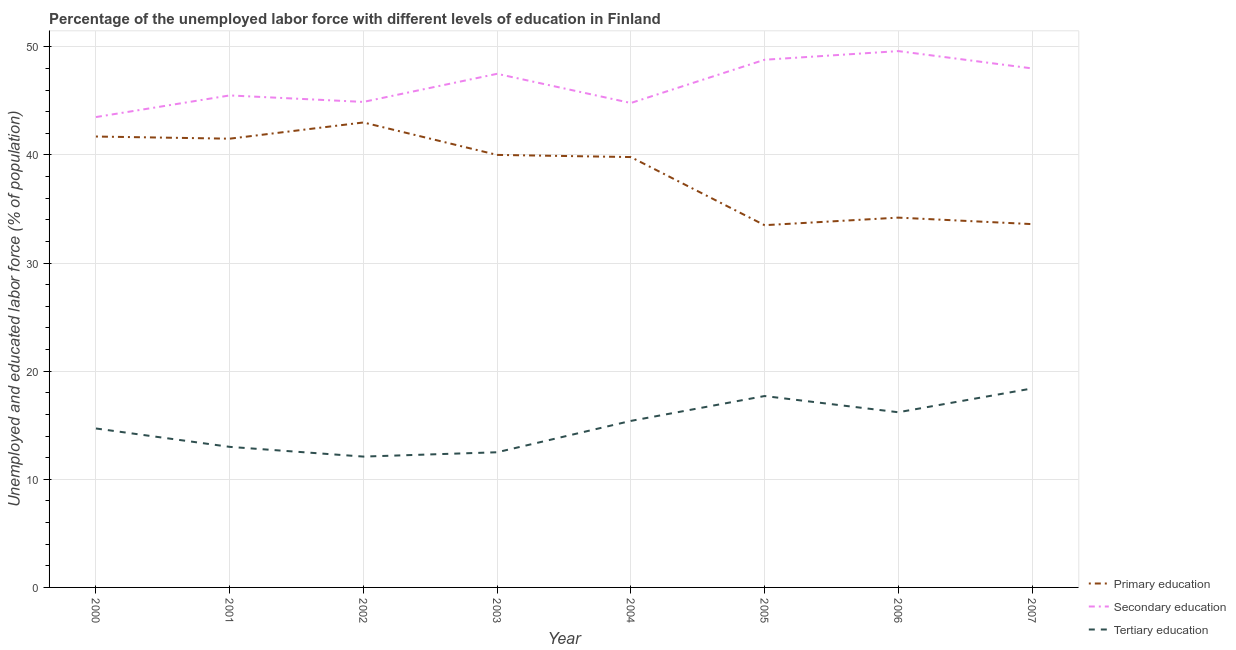Does the line corresponding to percentage of labor force who received secondary education intersect with the line corresponding to percentage of labor force who received tertiary education?
Your response must be concise. No. What is the percentage of labor force who received primary education in 2005?
Make the answer very short. 33.5. Across all years, what is the maximum percentage of labor force who received tertiary education?
Your response must be concise. 18.4. Across all years, what is the minimum percentage of labor force who received tertiary education?
Offer a terse response. 12.1. What is the total percentage of labor force who received primary education in the graph?
Ensure brevity in your answer.  307.3. What is the difference between the percentage of labor force who received secondary education in 2000 and that in 2004?
Make the answer very short. -1.3. What is the difference between the percentage of labor force who received tertiary education in 2005 and the percentage of labor force who received primary education in 2000?
Provide a short and direct response. -24. What is the average percentage of labor force who received tertiary education per year?
Your answer should be very brief. 15. In the year 2000, what is the difference between the percentage of labor force who received tertiary education and percentage of labor force who received primary education?
Your answer should be very brief. -27. What is the ratio of the percentage of labor force who received secondary education in 2005 to that in 2006?
Keep it short and to the point. 0.98. Is the percentage of labor force who received tertiary education in 2000 less than that in 2005?
Your answer should be compact. Yes. What is the difference between the highest and the second highest percentage of labor force who received primary education?
Offer a terse response. 1.3. What is the difference between the highest and the lowest percentage of labor force who received secondary education?
Make the answer very short. 6.1. Does the percentage of labor force who received primary education monotonically increase over the years?
Give a very brief answer. No. How many lines are there?
Give a very brief answer. 3. Are the values on the major ticks of Y-axis written in scientific E-notation?
Provide a succinct answer. No. What is the title of the graph?
Provide a succinct answer. Percentage of the unemployed labor force with different levels of education in Finland. Does "Refusal of sex" appear as one of the legend labels in the graph?
Your response must be concise. No. What is the label or title of the Y-axis?
Offer a very short reply. Unemployed and educated labor force (% of population). What is the Unemployed and educated labor force (% of population) in Primary education in 2000?
Keep it short and to the point. 41.7. What is the Unemployed and educated labor force (% of population) in Secondary education in 2000?
Give a very brief answer. 43.5. What is the Unemployed and educated labor force (% of population) of Tertiary education in 2000?
Give a very brief answer. 14.7. What is the Unemployed and educated labor force (% of population) of Primary education in 2001?
Provide a short and direct response. 41.5. What is the Unemployed and educated labor force (% of population) in Secondary education in 2001?
Offer a very short reply. 45.5. What is the Unemployed and educated labor force (% of population) of Primary education in 2002?
Offer a very short reply. 43. What is the Unemployed and educated labor force (% of population) of Secondary education in 2002?
Provide a short and direct response. 44.9. What is the Unemployed and educated labor force (% of population) in Tertiary education in 2002?
Offer a very short reply. 12.1. What is the Unemployed and educated labor force (% of population) of Primary education in 2003?
Your response must be concise. 40. What is the Unemployed and educated labor force (% of population) of Secondary education in 2003?
Provide a succinct answer. 47.5. What is the Unemployed and educated labor force (% of population) of Tertiary education in 2003?
Offer a terse response. 12.5. What is the Unemployed and educated labor force (% of population) in Primary education in 2004?
Your answer should be compact. 39.8. What is the Unemployed and educated labor force (% of population) in Secondary education in 2004?
Ensure brevity in your answer.  44.8. What is the Unemployed and educated labor force (% of population) in Tertiary education in 2004?
Ensure brevity in your answer.  15.4. What is the Unemployed and educated labor force (% of population) in Primary education in 2005?
Offer a terse response. 33.5. What is the Unemployed and educated labor force (% of population) of Secondary education in 2005?
Ensure brevity in your answer.  48.8. What is the Unemployed and educated labor force (% of population) of Tertiary education in 2005?
Provide a short and direct response. 17.7. What is the Unemployed and educated labor force (% of population) of Primary education in 2006?
Your answer should be very brief. 34.2. What is the Unemployed and educated labor force (% of population) in Secondary education in 2006?
Offer a very short reply. 49.6. What is the Unemployed and educated labor force (% of population) in Tertiary education in 2006?
Provide a succinct answer. 16.2. What is the Unemployed and educated labor force (% of population) of Primary education in 2007?
Offer a terse response. 33.6. What is the Unemployed and educated labor force (% of population) of Tertiary education in 2007?
Keep it short and to the point. 18.4. Across all years, what is the maximum Unemployed and educated labor force (% of population) in Primary education?
Offer a terse response. 43. Across all years, what is the maximum Unemployed and educated labor force (% of population) in Secondary education?
Your response must be concise. 49.6. Across all years, what is the maximum Unemployed and educated labor force (% of population) of Tertiary education?
Make the answer very short. 18.4. Across all years, what is the minimum Unemployed and educated labor force (% of population) of Primary education?
Offer a very short reply. 33.5. Across all years, what is the minimum Unemployed and educated labor force (% of population) in Secondary education?
Your answer should be compact. 43.5. Across all years, what is the minimum Unemployed and educated labor force (% of population) of Tertiary education?
Provide a succinct answer. 12.1. What is the total Unemployed and educated labor force (% of population) in Primary education in the graph?
Your answer should be compact. 307.3. What is the total Unemployed and educated labor force (% of population) of Secondary education in the graph?
Provide a succinct answer. 372.6. What is the total Unemployed and educated labor force (% of population) of Tertiary education in the graph?
Offer a terse response. 120. What is the difference between the Unemployed and educated labor force (% of population) in Secondary education in 2000 and that in 2001?
Make the answer very short. -2. What is the difference between the Unemployed and educated labor force (% of population) of Secondary education in 2000 and that in 2002?
Ensure brevity in your answer.  -1.4. What is the difference between the Unemployed and educated labor force (% of population) of Tertiary education in 2000 and that in 2002?
Your answer should be very brief. 2.6. What is the difference between the Unemployed and educated labor force (% of population) of Secondary education in 2000 and that in 2004?
Offer a terse response. -1.3. What is the difference between the Unemployed and educated labor force (% of population) in Secondary education in 2000 and that in 2005?
Keep it short and to the point. -5.3. What is the difference between the Unemployed and educated labor force (% of population) of Secondary education in 2000 and that in 2006?
Your answer should be compact. -6.1. What is the difference between the Unemployed and educated labor force (% of population) of Primary education in 2000 and that in 2007?
Keep it short and to the point. 8.1. What is the difference between the Unemployed and educated labor force (% of population) in Secondary education in 2000 and that in 2007?
Give a very brief answer. -4.5. What is the difference between the Unemployed and educated labor force (% of population) of Tertiary education in 2000 and that in 2007?
Offer a very short reply. -3.7. What is the difference between the Unemployed and educated labor force (% of population) of Primary education in 2001 and that in 2002?
Your response must be concise. -1.5. What is the difference between the Unemployed and educated labor force (% of population) in Secondary education in 2001 and that in 2002?
Provide a succinct answer. 0.6. What is the difference between the Unemployed and educated labor force (% of population) of Primary education in 2001 and that in 2003?
Make the answer very short. 1.5. What is the difference between the Unemployed and educated labor force (% of population) in Secondary education in 2001 and that in 2003?
Give a very brief answer. -2. What is the difference between the Unemployed and educated labor force (% of population) in Primary education in 2001 and that in 2004?
Your answer should be very brief. 1.7. What is the difference between the Unemployed and educated labor force (% of population) in Primary education in 2001 and that in 2005?
Offer a terse response. 8. What is the difference between the Unemployed and educated labor force (% of population) of Secondary education in 2001 and that in 2007?
Provide a succinct answer. -2.5. What is the difference between the Unemployed and educated labor force (% of population) of Primary education in 2002 and that in 2003?
Ensure brevity in your answer.  3. What is the difference between the Unemployed and educated labor force (% of population) in Secondary education in 2002 and that in 2003?
Offer a terse response. -2.6. What is the difference between the Unemployed and educated labor force (% of population) of Tertiary education in 2002 and that in 2003?
Make the answer very short. -0.4. What is the difference between the Unemployed and educated labor force (% of population) of Primary education in 2002 and that in 2004?
Provide a short and direct response. 3.2. What is the difference between the Unemployed and educated labor force (% of population) in Secondary education in 2002 and that in 2004?
Make the answer very short. 0.1. What is the difference between the Unemployed and educated labor force (% of population) in Primary education in 2002 and that in 2005?
Provide a succinct answer. 9.5. What is the difference between the Unemployed and educated labor force (% of population) in Secondary education in 2002 and that in 2005?
Provide a succinct answer. -3.9. What is the difference between the Unemployed and educated labor force (% of population) of Secondary education in 2002 and that in 2006?
Your response must be concise. -4.7. What is the difference between the Unemployed and educated labor force (% of population) of Secondary education in 2002 and that in 2007?
Your response must be concise. -3.1. What is the difference between the Unemployed and educated labor force (% of population) in Tertiary education in 2002 and that in 2007?
Your answer should be compact. -6.3. What is the difference between the Unemployed and educated labor force (% of population) of Tertiary education in 2003 and that in 2004?
Provide a succinct answer. -2.9. What is the difference between the Unemployed and educated labor force (% of population) of Secondary education in 2003 and that in 2005?
Offer a terse response. -1.3. What is the difference between the Unemployed and educated labor force (% of population) in Tertiary education in 2003 and that in 2005?
Keep it short and to the point. -5.2. What is the difference between the Unemployed and educated labor force (% of population) of Tertiary education in 2003 and that in 2006?
Offer a very short reply. -3.7. What is the difference between the Unemployed and educated labor force (% of population) in Primary education in 2003 and that in 2007?
Your answer should be compact. 6.4. What is the difference between the Unemployed and educated labor force (% of population) of Secondary education in 2003 and that in 2007?
Your answer should be compact. -0.5. What is the difference between the Unemployed and educated labor force (% of population) in Tertiary education in 2003 and that in 2007?
Give a very brief answer. -5.9. What is the difference between the Unemployed and educated labor force (% of population) in Primary education in 2004 and that in 2005?
Offer a very short reply. 6.3. What is the difference between the Unemployed and educated labor force (% of population) of Secondary education in 2004 and that in 2005?
Provide a short and direct response. -4. What is the difference between the Unemployed and educated labor force (% of population) of Primary education in 2004 and that in 2006?
Your answer should be very brief. 5.6. What is the difference between the Unemployed and educated labor force (% of population) in Secondary education in 2004 and that in 2006?
Offer a terse response. -4.8. What is the difference between the Unemployed and educated labor force (% of population) of Primary education in 2004 and that in 2007?
Make the answer very short. 6.2. What is the difference between the Unemployed and educated labor force (% of population) in Primary education in 2005 and that in 2007?
Your response must be concise. -0.1. What is the difference between the Unemployed and educated labor force (% of population) in Secondary education in 2005 and that in 2007?
Offer a very short reply. 0.8. What is the difference between the Unemployed and educated labor force (% of population) of Primary education in 2006 and that in 2007?
Keep it short and to the point. 0.6. What is the difference between the Unemployed and educated labor force (% of population) in Primary education in 2000 and the Unemployed and educated labor force (% of population) in Secondary education in 2001?
Your response must be concise. -3.8. What is the difference between the Unemployed and educated labor force (% of population) in Primary education in 2000 and the Unemployed and educated labor force (% of population) in Tertiary education in 2001?
Keep it short and to the point. 28.7. What is the difference between the Unemployed and educated labor force (% of population) of Secondary education in 2000 and the Unemployed and educated labor force (% of population) of Tertiary education in 2001?
Your answer should be compact. 30.5. What is the difference between the Unemployed and educated labor force (% of population) in Primary education in 2000 and the Unemployed and educated labor force (% of population) in Secondary education in 2002?
Keep it short and to the point. -3.2. What is the difference between the Unemployed and educated labor force (% of population) in Primary education in 2000 and the Unemployed and educated labor force (% of population) in Tertiary education in 2002?
Your response must be concise. 29.6. What is the difference between the Unemployed and educated labor force (% of population) in Secondary education in 2000 and the Unemployed and educated labor force (% of population) in Tertiary education in 2002?
Make the answer very short. 31.4. What is the difference between the Unemployed and educated labor force (% of population) of Primary education in 2000 and the Unemployed and educated labor force (% of population) of Tertiary education in 2003?
Offer a terse response. 29.2. What is the difference between the Unemployed and educated labor force (% of population) in Primary education in 2000 and the Unemployed and educated labor force (% of population) in Tertiary education in 2004?
Offer a terse response. 26.3. What is the difference between the Unemployed and educated labor force (% of population) in Secondary education in 2000 and the Unemployed and educated labor force (% of population) in Tertiary education in 2004?
Make the answer very short. 28.1. What is the difference between the Unemployed and educated labor force (% of population) of Primary education in 2000 and the Unemployed and educated labor force (% of population) of Secondary education in 2005?
Your answer should be very brief. -7.1. What is the difference between the Unemployed and educated labor force (% of population) in Primary education in 2000 and the Unemployed and educated labor force (% of population) in Tertiary education in 2005?
Offer a terse response. 24. What is the difference between the Unemployed and educated labor force (% of population) in Secondary education in 2000 and the Unemployed and educated labor force (% of population) in Tertiary education in 2005?
Offer a terse response. 25.8. What is the difference between the Unemployed and educated labor force (% of population) of Primary education in 2000 and the Unemployed and educated labor force (% of population) of Secondary education in 2006?
Keep it short and to the point. -7.9. What is the difference between the Unemployed and educated labor force (% of population) of Primary education in 2000 and the Unemployed and educated labor force (% of population) of Tertiary education in 2006?
Offer a very short reply. 25.5. What is the difference between the Unemployed and educated labor force (% of population) of Secondary education in 2000 and the Unemployed and educated labor force (% of population) of Tertiary education in 2006?
Offer a very short reply. 27.3. What is the difference between the Unemployed and educated labor force (% of population) in Primary education in 2000 and the Unemployed and educated labor force (% of population) in Secondary education in 2007?
Keep it short and to the point. -6.3. What is the difference between the Unemployed and educated labor force (% of population) of Primary education in 2000 and the Unemployed and educated labor force (% of population) of Tertiary education in 2007?
Keep it short and to the point. 23.3. What is the difference between the Unemployed and educated labor force (% of population) in Secondary education in 2000 and the Unemployed and educated labor force (% of population) in Tertiary education in 2007?
Your response must be concise. 25.1. What is the difference between the Unemployed and educated labor force (% of population) in Primary education in 2001 and the Unemployed and educated labor force (% of population) in Tertiary education in 2002?
Make the answer very short. 29.4. What is the difference between the Unemployed and educated labor force (% of population) of Secondary education in 2001 and the Unemployed and educated labor force (% of population) of Tertiary education in 2002?
Provide a short and direct response. 33.4. What is the difference between the Unemployed and educated labor force (% of population) in Primary education in 2001 and the Unemployed and educated labor force (% of population) in Secondary education in 2003?
Offer a very short reply. -6. What is the difference between the Unemployed and educated labor force (% of population) of Primary education in 2001 and the Unemployed and educated labor force (% of population) of Tertiary education in 2003?
Provide a short and direct response. 29. What is the difference between the Unemployed and educated labor force (% of population) in Primary education in 2001 and the Unemployed and educated labor force (% of population) in Secondary education in 2004?
Keep it short and to the point. -3.3. What is the difference between the Unemployed and educated labor force (% of population) in Primary education in 2001 and the Unemployed and educated labor force (% of population) in Tertiary education in 2004?
Offer a terse response. 26.1. What is the difference between the Unemployed and educated labor force (% of population) in Secondary education in 2001 and the Unemployed and educated labor force (% of population) in Tertiary education in 2004?
Offer a terse response. 30.1. What is the difference between the Unemployed and educated labor force (% of population) of Primary education in 2001 and the Unemployed and educated labor force (% of population) of Secondary education in 2005?
Provide a short and direct response. -7.3. What is the difference between the Unemployed and educated labor force (% of population) of Primary education in 2001 and the Unemployed and educated labor force (% of population) of Tertiary education in 2005?
Your answer should be very brief. 23.8. What is the difference between the Unemployed and educated labor force (% of population) in Secondary education in 2001 and the Unemployed and educated labor force (% of population) in Tertiary education in 2005?
Your answer should be compact. 27.8. What is the difference between the Unemployed and educated labor force (% of population) of Primary education in 2001 and the Unemployed and educated labor force (% of population) of Secondary education in 2006?
Your answer should be very brief. -8.1. What is the difference between the Unemployed and educated labor force (% of population) of Primary education in 2001 and the Unemployed and educated labor force (% of population) of Tertiary education in 2006?
Keep it short and to the point. 25.3. What is the difference between the Unemployed and educated labor force (% of population) in Secondary education in 2001 and the Unemployed and educated labor force (% of population) in Tertiary education in 2006?
Provide a succinct answer. 29.3. What is the difference between the Unemployed and educated labor force (% of population) in Primary education in 2001 and the Unemployed and educated labor force (% of population) in Secondary education in 2007?
Offer a very short reply. -6.5. What is the difference between the Unemployed and educated labor force (% of population) in Primary education in 2001 and the Unemployed and educated labor force (% of population) in Tertiary education in 2007?
Give a very brief answer. 23.1. What is the difference between the Unemployed and educated labor force (% of population) in Secondary education in 2001 and the Unemployed and educated labor force (% of population) in Tertiary education in 2007?
Your answer should be compact. 27.1. What is the difference between the Unemployed and educated labor force (% of population) of Primary education in 2002 and the Unemployed and educated labor force (% of population) of Tertiary education in 2003?
Make the answer very short. 30.5. What is the difference between the Unemployed and educated labor force (% of population) of Secondary education in 2002 and the Unemployed and educated labor force (% of population) of Tertiary education in 2003?
Offer a terse response. 32.4. What is the difference between the Unemployed and educated labor force (% of population) of Primary education in 2002 and the Unemployed and educated labor force (% of population) of Tertiary education in 2004?
Give a very brief answer. 27.6. What is the difference between the Unemployed and educated labor force (% of population) of Secondary education in 2002 and the Unemployed and educated labor force (% of population) of Tertiary education in 2004?
Your response must be concise. 29.5. What is the difference between the Unemployed and educated labor force (% of population) in Primary education in 2002 and the Unemployed and educated labor force (% of population) in Tertiary education in 2005?
Ensure brevity in your answer.  25.3. What is the difference between the Unemployed and educated labor force (% of population) of Secondary education in 2002 and the Unemployed and educated labor force (% of population) of Tertiary education in 2005?
Offer a very short reply. 27.2. What is the difference between the Unemployed and educated labor force (% of population) of Primary education in 2002 and the Unemployed and educated labor force (% of population) of Secondary education in 2006?
Ensure brevity in your answer.  -6.6. What is the difference between the Unemployed and educated labor force (% of population) in Primary education in 2002 and the Unemployed and educated labor force (% of population) in Tertiary education in 2006?
Provide a succinct answer. 26.8. What is the difference between the Unemployed and educated labor force (% of population) of Secondary education in 2002 and the Unemployed and educated labor force (% of population) of Tertiary education in 2006?
Give a very brief answer. 28.7. What is the difference between the Unemployed and educated labor force (% of population) of Primary education in 2002 and the Unemployed and educated labor force (% of population) of Tertiary education in 2007?
Keep it short and to the point. 24.6. What is the difference between the Unemployed and educated labor force (% of population) of Secondary education in 2002 and the Unemployed and educated labor force (% of population) of Tertiary education in 2007?
Provide a short and direct response. 26.5. What is the difference between the Unemployed and educated labor force (% of population) of Primary education in 2003 and the Unemployed and educated labor force (% of population) of Secondary education in 2004?
Your answer should be very brief. -4.8. What is the difference between the Unemployed and educated labor force (% of population) in Primary education in 2003 and the Unemployed and educated labor force (% of population) in Tertiary education in 2004?
Provide a short and direct response. 24.6. What is the difference between the Unemployed and educated labor force (% of population) in Secondary education in 2003 and the Unemployed and educated labor force (% of population) in Tertiary education in 2004?
Ensure brevity in your answer.  32.1. What is the difference between the Unemployed and educated labor force (% of population) of Primary education in 2003 and the Unemployed and educated labor force (% of population) of Secondary education in 2005?
Your answer should be very brief. -8.8. What is the difference between the Unemployed and educated labor force (% of population) in Primary education in 2003 and the Unemployed and educated labor force (% of population) in Tertiary education in 2005?
Ensure brevity in your answer.  22.3. What is the difference between the Unemployed and educated labor force (% of population) in Secondary education in 2003 and the Unemployed and educated labor force (% of population) in Tertiary education in 2005?
Make the answer very short. 29.8. What is the difference between the Unemployed and educated labor force (% of population) of Primary education in 2003 and the Unemployed and educated labor force (% of population) of Secondary education in 2006?
Keep it short and to the point. -9.6. What is the difference between the Unemployed and educated labor force (% of population) in Primary education in 2003 and the Unemployed and educated labor force (% of population) in Tertiary education in 2006?
Provide a succinct answer. 23.8. What is the difference between the Unemployed and educated labor force (% of population) of Secondary education in 2003 and the Unemployed and educated labor force (% of population) of Tertiary education in 2006?
Give a very brief answer. 31.3. What is the difference between the Unemployed and educated labor force (% of population) of Primary education in 2003 and the Unemployed and educated labor force (% of population) of Tertiary education in 2007?
Keep it short and to the point. 21.6. What is the difference between the Unemployed and educated labor force (% of population) of Secondary education in 2003 and the Unemployed and educated labor force (% of population) of Tertiary education in 2007?
Give a very brief answer. 29.1. What is the difference between the Unemployed and educated labor force (% of population) of Primary education in 2004 and the Unemployed and educated labor force (% of population) of Tertiary education in 2005?
Ensure brevity in your answer.  22.1. What is the difference between the Unemployed and educated labor force (% of population) in Secondary education in 2004 and the Unemployed and educated labor force (% of population) in Tertiary education in 2005?
Keep it short and to the point. 27.1. What is the difference between the Unemployed and educated labor force (% of population) in Primary education in 2004 and the Unemployed and educated labor force (% of population) in Secondary education in 2006?
Keep it short and to the point. -9.8. What is the difference between the Unemployed and educated labor force (% of population) of Primary education in 2004 and the Unemployed and educated labor force (% of population) of Tertiary education in 2006?
Ensure brevity in your answer.  23.6. What is the difference between the Unemployed and educated labor force (% of population) in Secondary education in 2004 and the Unemployed and educated labor force (% of population) in Tertiary education in 2006?
Your response must be concise. 28.6. What is the difference between the Unemployed and educated labor force (% of population) in Primary education in 2004 and the Unemployed and educated labor force (% of population) in Tertiary education in 2007?
Offer a terse response. 21.4. What is the difference between the Unemployed and educated labor force (% of population) of Secondary education in 2004 and the Unemployed and educated labor force (% of population) of Tertiary education in 2007?
Your answer should be compact. 26.4. What is the difference between the Unemployed and educated labor force (% of population) in Primary education in 2005 and the Unemployed and educated labor force (% of population) in Secondary education in 2006?
Keep it short and to the point. -16.1. What is the difference between the Unemployed and educated labor force (% of population) of Primary education in 2005 and the Unemployed and educated labor force (% of population) of Tertiary education in 2006?
Make the answer very short. 17.3. What is the difference between the Unemployed and educated labor force (% of population) of Secondary education in 2005 and the Unemployed and educated labor force (% of population) of Tertiary education in 2006?
Keep it short and to the point. 32.6. What is the difference between the Unemployed and educated labor force (% of population) in Primary education in 2005 and the Unemployed and educated labor force (% of population) in Tertiary education in 2007?
Your response must be concise. 15.1. What is the difference between the Unemployed and educated labor force (% of population) of Secondary education in 2005 and the Unemployed and educated labor force (% of population) of Tertiary education in 2007?
Provide a short and direct response. 30.4. What is the difference between the Unemployed and educated labor force (% of population) of Primary education in 2006 and the Unemployed and educated labor force (% of population) of Tertiary education in 2007?
Your answer should be very brief. 15.8. What is the difference between the Unemployed and educated labor force (% of population) of Secondary education in 2006 and the Unemployed and educated labor force (% of population) of Tertiary education in 2007?
Offer a very short reply. 31.2. What is the average Unemployed and educated labor force (% of population) of Primary education per year?
Your response must be concise. 38.41. What is the average Unemployed and educated labor force (% of population) in Secondary education per year?
Your response must be concise. 46.58. In the year 2000, what is the difference between the Unemployed and educated labor force (% of population) of Primary education and Unemployed and educated labor force (% of population) of Tertiary education?
Make the answer very short. 27. In the year 2000, what is the difference between the Unemployed and educated labor force (% of population) of Secondary education and Unemployed and educated labor force (% of population) of Tertiary education?
Offer a very short reply. 28.8. In the year 2001, what is the difference between the Unemployed and educated labor force (% of population) in Primary education and Unemployed and educated labor force (% of population) in Secondary education?
Offer a very short reply. -4. In the year 2001, what is the difference between the Unemployed and educated labor force (% of population) of Secondary education and Unemployed and educated labor force (% of population) of Tertiary education?
Your response must be concise. 32.5. In the year 2002, what is the difference between the Unemployed and educated labor force (% of population) in Primary education and Unemployed and educated labor force (% of population) in Tertiary education?
Your answer should be compact. 30.9. In the year 2002, what is the difference between the Unemployed and educated labor force (% of population) in Secondary education and Unemployed and educated labor force (% of population) in Tertiary education?
Your answer should be very brief. 32.8. In the year 2003, what is the difference between the Unemployed and educated labor force (% of population) in Primary education and Unemployed and educated labor force (% of population) in Tertiary education?
Give a very brief answer. 27.5. In the year 2004, what is the difference between the Unemployed and educated labor force (% of population) in Primary education and Unemployed and educated labor force (% of population) in Secondary education?
Ensure brevity in your answer.  -5. In the year 2004, what is the difference between the Unemployed and educated labor force (% of population) of Primary education and Unemployed and educated labor force (% of population) of Tertiary education?
Your response must be concise. 24.4. In the year 2004, what is the difference between the Unemployed and educated labor force (% of population) in Secondary education and Unemployed and educated labor force (% of population) in Tertiary education?
Ensure brevity in your answer.  29.4. In the year 2005, what is the difference between the Unemployed and educated labor force (% of population) of Primary education and Unemployed and educated labor force (% of population) of Secondary education?
Offer a very short reply. -15.3. In the year 2005, what is the difference between the Unemployed and educated labor force (% of population) of Secondary education and Unemployed and educated labor force (% of population) of Tertiary education?
Your response must be concise. 31.1. In the year 2006, what is the difference between the Unemployed and educated labor force (% of population) of Primary education and Unemployed and educated labor force (% of population) of Secondary education?
Provide a succinct answer. -15.4. In the year 2006, what is the difference between the Unemployed and educated labor force (% of population) in Secondary education and Unemployed and educated labor force (% of population) in Tertiary education?
Give a very brief answer. 33.4. In the year 2007, what is the difference between the Unemployed and educated labor force (% of population) in Primary education and Unemployed and educated labor force (% of population) in Secondary education?
Make the answer very short. -14.4. In the year 2007, what is the difference between the Unemployed and educated labor force (% of population) in Secondary education and Unemployed and educated labor force (% of population) in Tertiary education?
Offer a terse response. 29.6. What is the ratio of the Unemployed and educated labor force (% of population) of Primary education in 2000 to that in 2001?
Give a very brief answer. 1. What is the ratio of the Unemployed and educated labor force (% of population) of Secondary education in 2000 to that in 2001?
Your answer should be compact. 0.96. What is the ratio of the Unemployed and educated labor force (% of population) of Tertiary education in 2000 to that in 2001?
Your response must be concise. 1.13. What is the ratio of the Unemployed and educated labor force (% of population) in Primary education in 2000 to that in 2002?
Make the answer very short. 0.97. What is the ratio of the Unemployed and educated labor force (% of population) of Secondary education in 2000 to that in 2002?
Make the answer very short. 0.97. What is the ratio of the Unemployed and educated labor force (% of population) in Tertiary education in 2000 to that in 2002?
Give a very brief answer. 1.21. What is the ratio of the Unemployed and educated labor force (% of population) of Primary education in 2000 to that in 2003?
Your response must be concise. 1.04. What is the ratio of the Unemployed and educated labor force (% of population) in Secondary education in 2000 to that in 2003?
Your answer should be very brief. 0.92. What is the ratio of the Unemployed and educated labor force (% of population) of Tertiary education in 2000 to that in 2003?
Give a very brief answer. 1.18. What is the ratio of the Unemployed and educated labor force (% of population) in Primary education in 2000 to that in 2004?
Keep it short and to the point. 1.05. What is the ratio of the Unemployed and educated labor force (% of population) of Secondary education in 2000 to that in 2004?
Make the answer very short. 0.97. What is the ratio of the Unemployed and educated labor force (% of population) of Tertiary education in 2000 to that in 2004?
Your answer should be very brief. 0.95. What is the ratio of the Unemployed and educated labor force (% of population) of Primary education in 2000 to that in 2005?
Offer a terse response. 1.24. What is the ratio of the Unemployed and educated labor force (% of population) of Secondary education in 2000 to that in 2005?
Your response must be concise. 0.89. What is the ratio of the Unemployed and educated labor force (% of population) in Tertiary education in 2000 to that in 2005?
Ensure brevity in your answer.  0.83. What is the ratio of the Unemployed and educated labor force (% of population) of Primary education in 2000 to that in 2006?
Ensure brevity in your answer.  1.22. What is the ratio of the Unemployed and educated labor force (% of population) in Secondary education in 2000 to that in 2006?
Offer a very short reply. 0.88. What is the ratio of the Unemployed and educated labor force (% of population) of Tertiary education in 2000 to that in 2006?
Offer a very short reply. 0.91. What is the ratio of the Unemployed and educated labor force (% of population) of Primary education in 2000 to that in 2007?
Provide a succinct answer. 1.24. What is the ratio of the Unemployed and educated labor force (% of population) of Secondary education in 2000 to that in 2007?
Offer a terse response. 0.91. What is the ratio of the Unemployed and educated labor force (% of population) of Tertiary education in 2000 to that in 2007?
Ensure brevity in your answer.  0.8. What is the ratio of the Unemployed and educated labor force (% of population) of Primary education in 2001 to that in 2002?
Keep it short and to the point. 0.97. What is the ratio of the Unemployed and educated labor force (% of population) of Secondary education in 2001 to that in 2002?
Provide a succinct answer. 1.01. What is the ratio of the Unemployed and educated labor force (% of population) of Tertiary education in 2001 to that in 2002?
Make the answer very short. 1.07. What is the ratio of the Unemployed and educated labor force (% of population) in Primary education in 2001 to that in 2003?
Give a very brief answer. 1.04. What is the ratio of the Unemployed and educated labor force (% of population) of Secondary education in 2001 to that in 2003?
Offer a terse response. 0.96. What is the ratio of the Unemployed and educated labor force (% of population) of Primary education in 2001 to that in 2004?
Ensure brevity in your answer.  1.04. What is the ratio of the Unemployed and educated labor force (% of population) of Secondary education in 2001 to that in 2004?
Your answer should be compact. 1.02. What is the ratio of the Unemployed and educated labor force (% of population) of Tertiary education in 2001 to that in 2004?
Your response must be concise. 0.84. What is the ratio of the Unemployed and educated labor force (% of population) in Primary education in 2001 to that in 2005?
Your answer should be very brief. 1.24. What is the ratio of the Unemployed and educated labor force (% of population) of Secondary education in 2001 to that in 2005?
Offer a very short reply. 0.93. What is the ratio of the Unemployed and educated labor force (% of population) of Tertiary education in 2001 to that in 2005?
Give a very brief answer. 0.73. What is the ratio of the Unemployed and educated labor force (% of population) in Primary education in 2001 to that in 2006?
Keep it short and to the point. 1.21. What is the ratio of the Unemployed and educated labor force (% of population) of Secondary education in 2001 to that in 2006?
Your response must be concise. 0.92. What is the ratio of the Unemployed and educated labor force (% of population) of Tertiary education in 2001 to that in 2006?
Provide a short and direct response. 0.8. What is the ratio of the Unemployed and educated labor force (% of population) in Primary education in 2001 to that in 2007?
Provide a succinct answer. 1.24. What is the ratio of the Unemployed and educated labor force (% of population) in Secondary education in 2001 to that in 2007?
Your response must be concise. 0.95. What is the ratio of the Unemployed and educated labor force (% of population) of Tertiary education in 2001 to that in 2007?
Your response must be concise. 0.71. What is the ratio of the Unemployed and educated labor force (% of population) of Primary education in 2002 to that in 2003?
Provide a succinct answer. 1.07. What is the ratio of the Unemployed and educated labor force (% of population) in Secondary education in 2002 to that in 2003?
Ensure brevity in your answer.  0.95. What is the ratio of the Unemployed and educated labor force (% of population) of Tertiary education in 2002 to that in 2003?
Your answer should be very brief. 0.97. What is the ratio of the Unemployed and educated labor force (% of population) of Primary education in 2002 to that in 2004?
Provide a succinct answer. 1.08. What is the ratio of the Unemployed and educated labor force (% of population) in Secondary education in 2002 to that in 2004?
Provide a succinct answer. 1. What is the ratio of the Unemployed and educated labor force (% of population) in Tertiary education in 2002 to that in 2004?
Keep it short and to the point. 0.79. What is the ratio of the Unemployed and educated labor force (% of population) in Primary education in 2002 to that in 2005?
Provide a short and direct response. 1.28. What is the ratio of the Unemployed and educated labor force (% of population) of Secondary education in 2002 to that in 2005?
Your answer should be very brief. 0.92. What is the ratio of the Unemployed and educated labor force (% of population) of Tertiary education in 2002 to that in 2005?
Make the answer very short. 0.68. What is the ratio of the Unemployed and educated labor force (% of population) of Primary education in 2002 to that in 2006?
Give a very brief answer. 1.26. What is the ratio of the Unemployed and educated labor force (% of population) of Secondary education in 2002 to that in 2006?
Make the answer very short. 0.91. What is the ratio of the Unemployed and educated labor force (% of population) in Tertiary education in 2002 to that in 2006?
Offer a terse response. 0.75. What is the ratio of the Unemployed and educated labor force (% of population) in Primary education in 2002 to that in 2007?
Your answer should be very brief. 1.28. What is the ratio of the Unemployed and educated labor force (% of population) of Secondary education in 2002 to that in 2007?
Make the answer very short. 0.94. What is the ratio of the Unemployed and educated labor force (% of population) of Tertiary education in 2002 to that in 2007?
Give a very brief answer. 0.66. What is the ratio of the Unemployed and educated labor force (% of population) in Secondary education in 2003 to that in 2004?
Ensure brevity in your answer.  1.06. What is the ratio of the Unemployed and educated labor force (% of population) in Tertiary education in 2003 to that in 2004?
Provide a short and direct response. 0.81. What is the ratio of the Unemployed and educated labor force (% of population) in Primary education in 2003 to that in 2005?
Provide a succinct answer. 1.19. What is the ratio of the Unemployed and educated labor force (% of population) in Secondary education in 2003 to that in 2005?
Keep it short and to the point. 0.97. What is the ratio of the Unemployed and educated labor force (% of population) in Tertiary education in 2003 to that in 2005?
Keep it short and to the point. 0.71. What is the ratio of the Unemployed and educated labor force (% of population) of Primary education in 2003 to that in 2006?
Give a very brief answer. 1.17. What is the ratio of the Unemployed and educated labor force (% of population) of Secondary education in 2003 to that in 2006?
Your answer should be compact. 0.96. What is the ratio of the Unemployed and educated labor force (% of population) of Tertiary education in 2003 to that in 2006?
Your answer should be very brief. 0.77. What is the ratio of the Unemployed and educated labor force (% of population) in Primary education in 2003 to that in 2007?
Give a very brief answer. 1.19. What is the ratio of the Unemployed and educated labor force (% of population) in Tertiary education in 2003 to that in 2007?
Keep it short and to the point. 0.68. What is the ratio of the Unemployed and educated labor force (% of population) in Primary education in 2004 to that in 2005?
Keep it short and to the point. 1.19. What is the ratio of the Unemployed and educated labor force (% of population) of Secondary education in 2004 to that in 2005?
Provide a short and direct response. 0.92. What is the ratio of the Unemployed and educated labor force (% of population) in Tertiary education in 2004 to that in 2005?
Offer a terse response. 0.87. What is the ratio of the Unemployed and educated labor force (% of population) in Primary education in 2004 to that in 2006?
Give a very brief answer. 1.16. What is the ratio of the Unemployed and educated labor force (% of population) in Secondary education in 2004 to that in 2006?
Offer a very short reply. 0.9. What is the ratio of the Unemployed and educated labor force (% of population) in Tertiary education in 2004 to that in 2006?
Make the answer very short. 0.95. What is the ratio of the Unemployed and educated labor force (% of population) in Primary education in 2004 to that in 2007?
Your response must be concise. 1.18. What is the ratio of the Unemployed and educated labor force (% of population) in Secondary education in 2004 to that in 2007?
Give a very brief answer. 0.93. What is the ratio of the Unemployed and educated labor force (% of population) of Tertiary education in 2004 to that in 2007?
Provide a succinct answer. 0.84. What is the ratio of the Unemployed and educated labor force (% of population) of Primary education in 2005 to that in 2006?
Your answer should be very brief. 0.98. What is the ratio of the Unemployed and educated labor force (% of population) in Secondary education in 2005 to that in 2006?
Give a very brief answer. 0.98. What is the ratio of the Unemployed and educated labor force (% of population) of Tertiary education in 2005 to that in 2006?
Ensure brevity in your answer.  1.09. What is the ratio of the Unemployed and educated labor force (% of population) of Primary education in 2005 to that in 2007?
Provide a succinct answer. 1. What is the ratio of the Unemployed and educated labor force (% of population) in Secondary education in 2005 to that in 2007?
Your response must be concise. 1.02. What is the ratio of the Unemployed and educated labor force (% of population) in Primary education in 2006 to that in 2007?
Ensure brevity in your answer.  1.02. What is the ratio of the Unemployed and educated labor force (% of population) of Tertiary education in 2006 to that in 2007?
Offer a very short reply. 0.88. What is the difference between the highest and the second highest Unemployed and educated labor force (% of population) in Secondary education?
Your response must be concise. 0.8. What is the difference between the highest and the second highest Unemployed and educated labor force (% of population) in Tertiary education?
Ensure brevity in your answer.  0.7. What is the difference between the highest and the lowest Unemployed and educated labor force (% of population) in Secondary education?
Offer a very short reply. 6.1. What is the difference between the highest and the lowest Unemployed and educated labor force (% of population) in Tertiary education?
Offer a terse response. 6.3. 